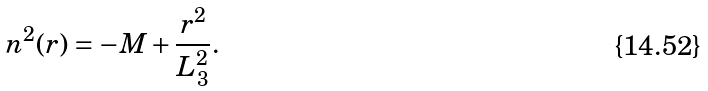Convert formula to latex. <formula><loc_0><loc_0><loc_500><loc_500>n ^ { 2 } ( r ) = - M + \frac { r ^ { 2 } } { L _ { 3 } ^ { 2 } } .</formula> 